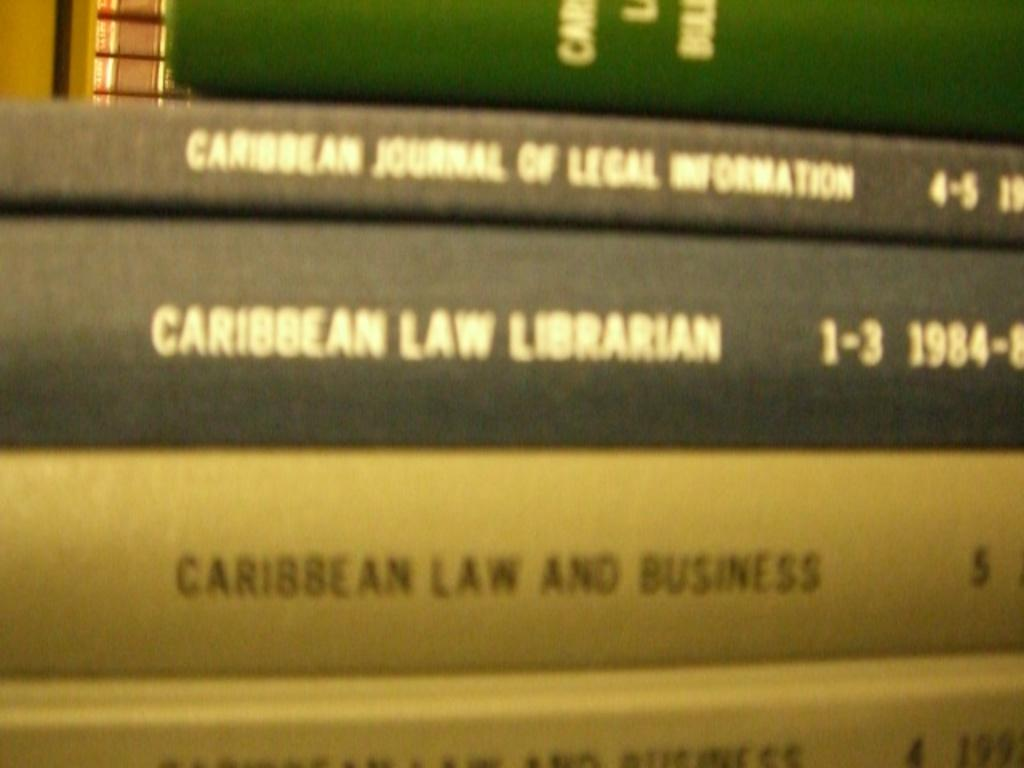<image>
Render a clear and concise summary of the photo. The books here are titled Caribbean Law and Business 